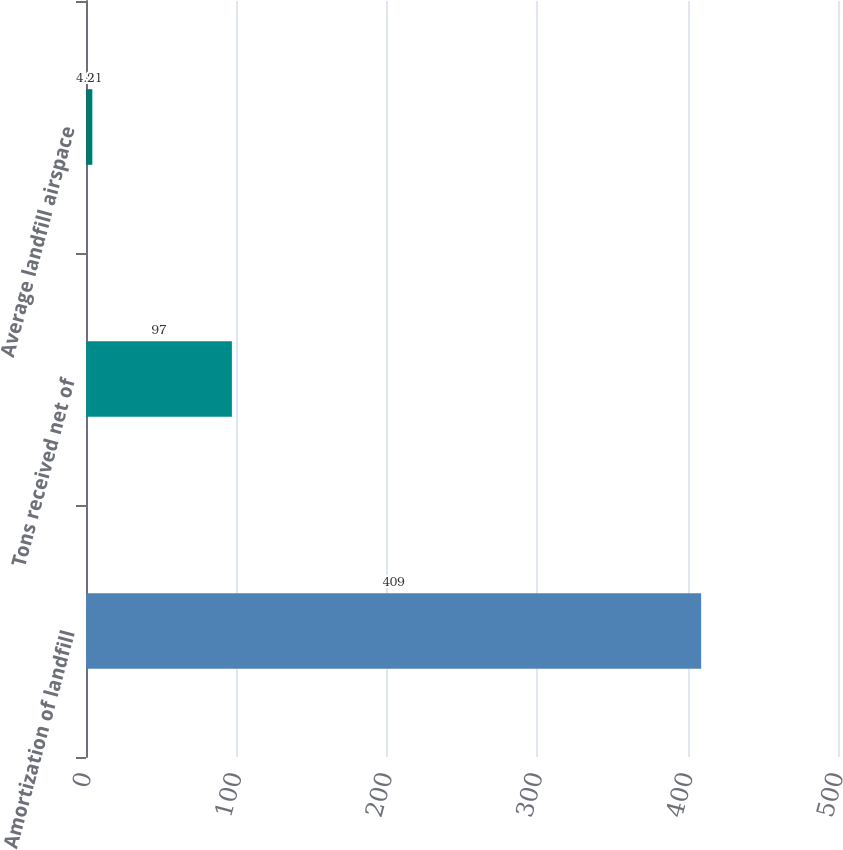<chart> <loc_0><loc_0><loc_500><loc_500><bar_chart><fcel>Amortization of landfill<fcel>Tons received net of<fcel>Average landfill airspace<nl><fcel>409<fcel>97<fcel>4.21<nl></chart> 